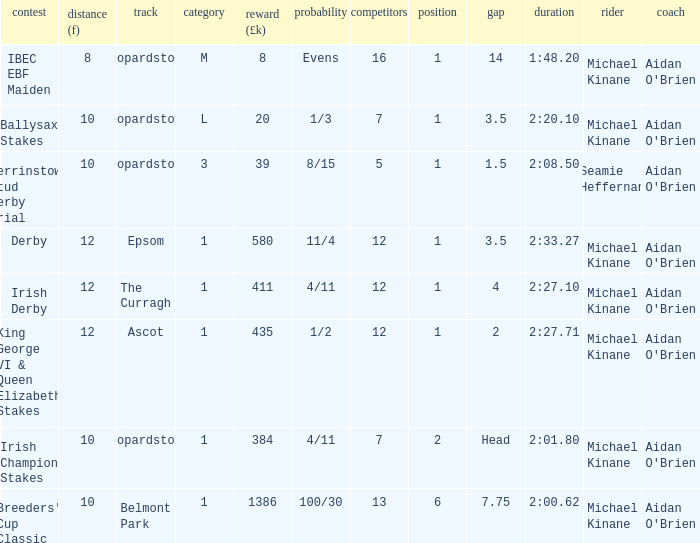Name the highest Dist (f) with Odds of 11/4 and a Placing larger than 1? None. 